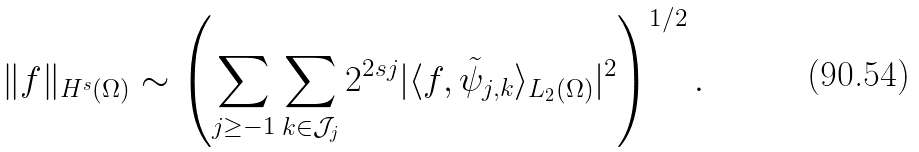<formula> <loc_0><loc_0><loc_500><loc_500>\| f \| _ { H ^ { s } ( \Omega ) } \sim \left ( \sum _ { j \geq - 1 } \sum _ { k \in \mathcal { J } _ { j } } 2 ^ { 2 s j } | \langle f , \tilde { \psi } _ { j , k } \rangle _ { L _ { 2 } ( \Omega ) } | ^ { 2 } \right ) ^ { 1 / 2 } .</formula> 